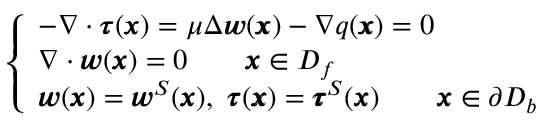Convert formula to latex. <formula><loc_0><loc_0><loc_500><loc_500>\left \{ \begin{array} { l l } { - \nabla \cdot { \pm b \tau } ( { \pm b x } ) = \mu \Delta { \pm b w } ( { \pm b x } ) - \nabla q ( { \pm b x } ) = 0 } \\ { \nabla \cdot { \pm b w } ( { \pm b x } ) = 0 \quad { \pm b x } \in D _ { f } } \\ { { \pm b w } ( { \pm b x } ) = { \pm b w } ^ { S } ( { \pm b x } ) , \ { \pm b \tau } ( { \pm b x } ) = { \pm b \tau } ^ { S } ( { \pm b x } ) \quad { \pm b x } \in \partial D _ { b } } \end{array}</formula> 